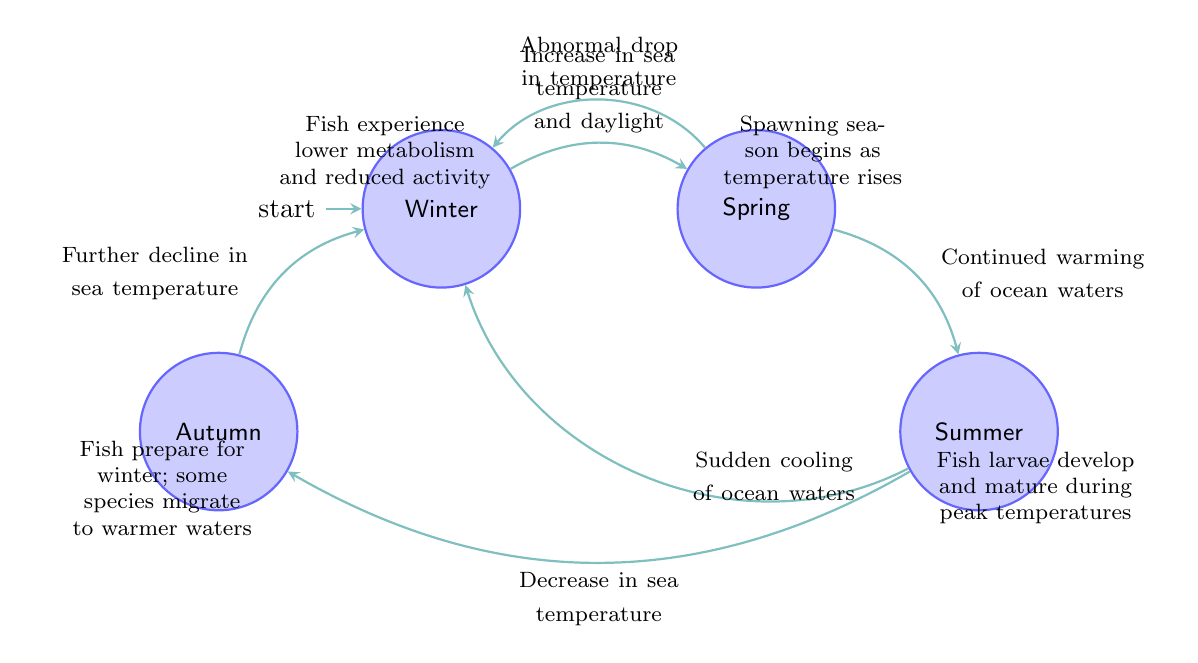What is the initial state in the diagram? The diagram indicates that the initial state is labeled "Winter." This can be identified from the fact that it is marked as "initial" in the node description.
Answer: Winter How many states are represented in the diagram? Upon inspecting the diagram, there are a total of four states: Winter, Spring, Summer, and Autumn. Counting these states provides the total number of states.
Answer: 4 What triggers the transition from Spring to Winter? The transition from Spring to Winter occurs due to an "Abnormal drop in temperature," as indicated by the label on the edge between these two states. This shows the specific condition for moving back to Winter.
Answer: Abnormal drop in temperature What occurs during the Summer state? The Summer state is described as a period when "Fish larvae develop and mature during peak temperatures." This description helps clarify the activities and biological processes taking place during this state.
Answer: Fish larvae develop and mature during peak temperatures What is the relationship between Autumn and Winter? The relationship is that Autumn transitions to Winter due to a "Further decline in sea temperature," indicating that as temperatures drop further, the state of Autumn leads to Winter in the cycle.
Answer: Further decline in sea temperature What would happen if there is a sudden cooling of ocean waters during Summer? If there is a sudden cooling of ocean waters during the Summer state, the diagram indicates that this would trigger a transition back to the Winter state, making it a critical condition leading to Winter.
Answer: Winter What is the primary activity of fish during the Spring state? According to the diagram, the primary activity during the Spring state is that "Spawning season begins as temperature rises," highlighting the reproductive cycle of fish during this time.
Answer: Spawning season begins as temperature rises How do fish react in Winter according to the diagram? The diagram specifies that during Winter, "Fish experience lower metabolism and reduced activity," indicating the physiological responses of fish during this cold season.
Answer: Lower metabolism and reduced activity 